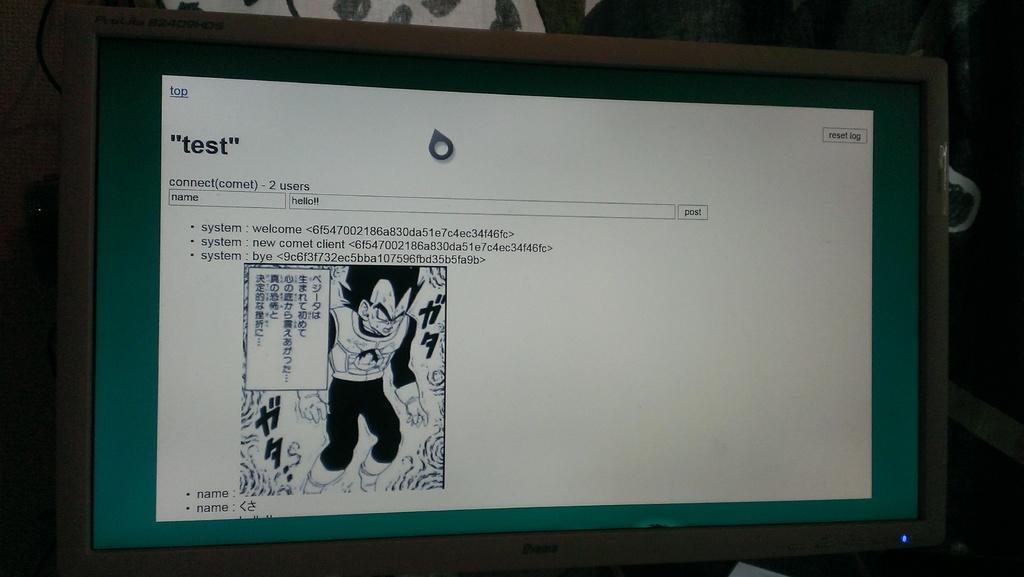Provide a one-sentence caption for the provided image. Computer screen with a Anime character of a mad looking monster that says test at the top of the screen. 